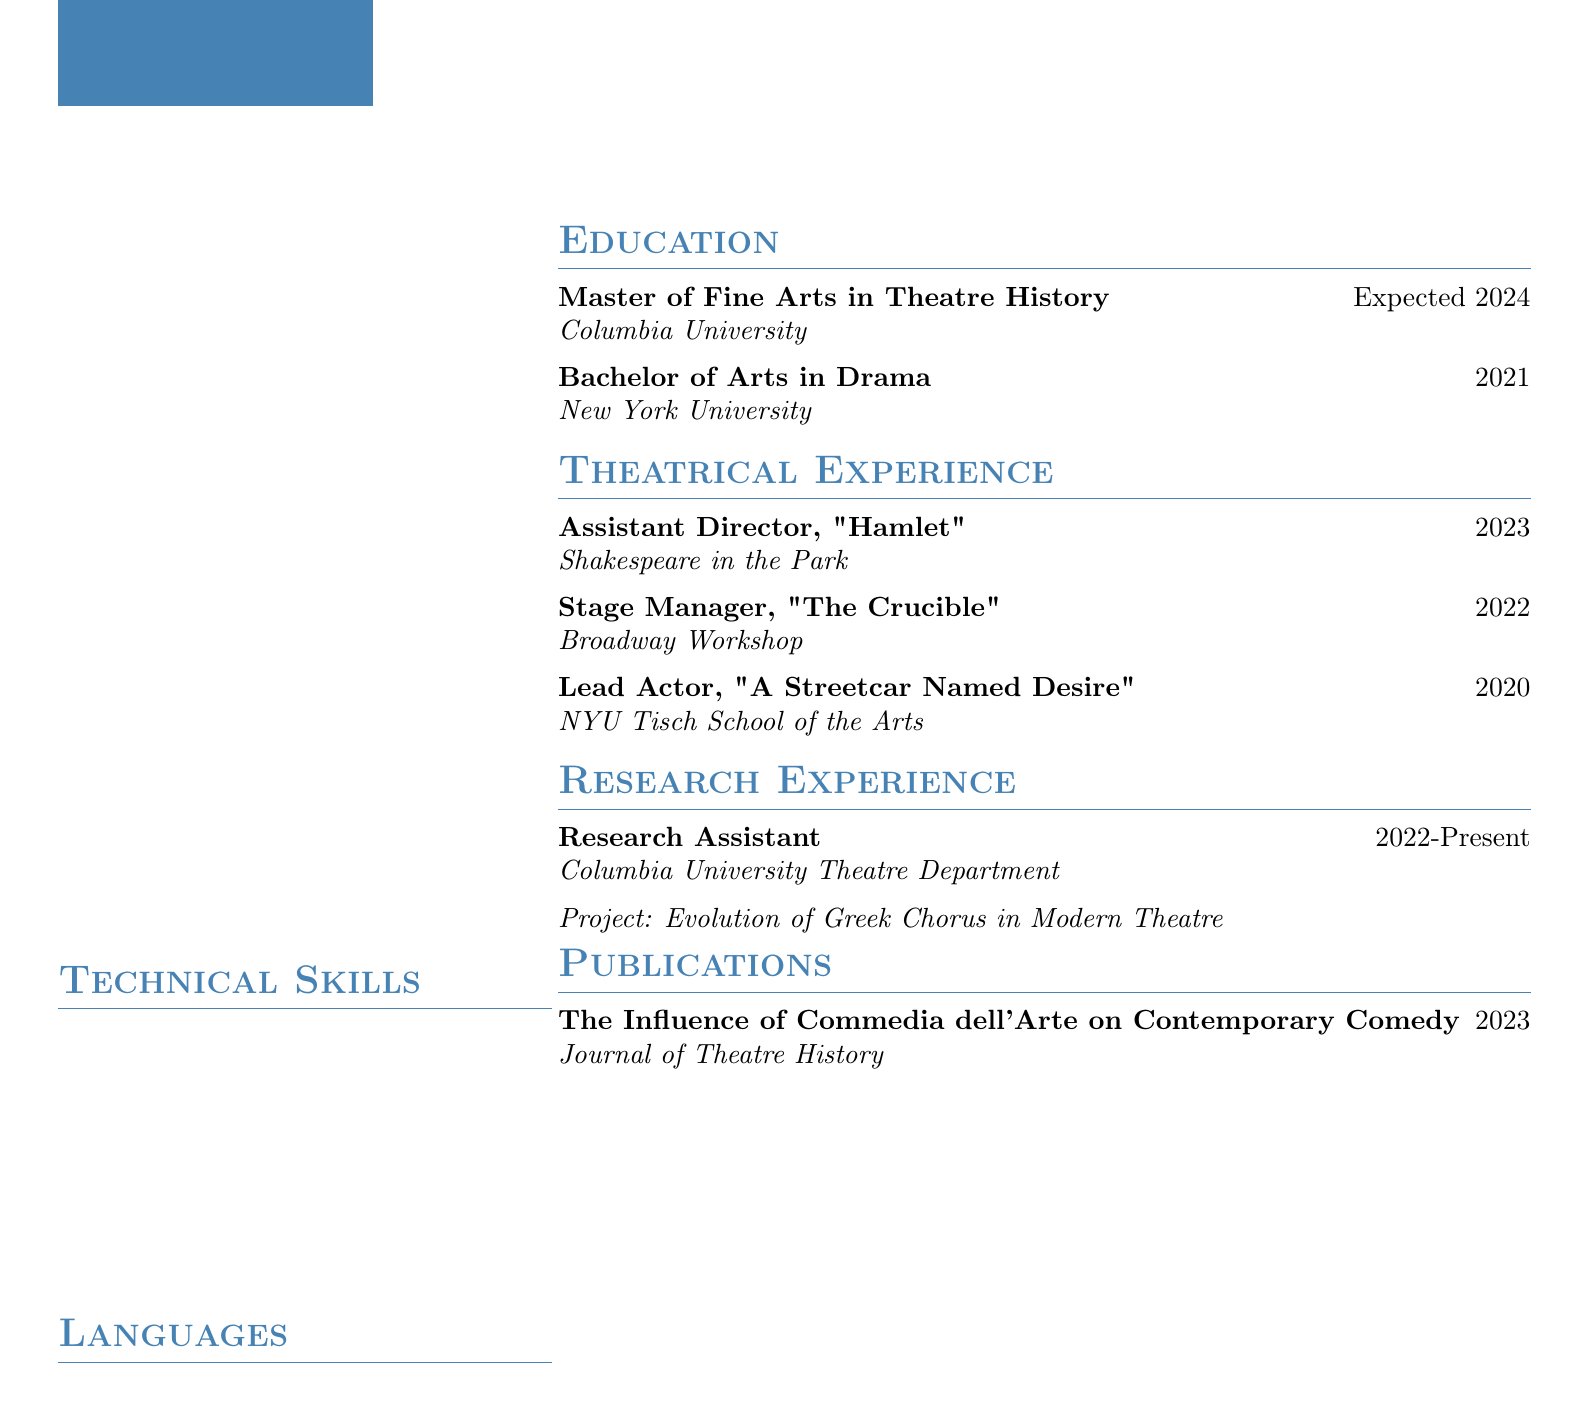What is the expected year of graduation? The expected year of graduation is listed under education.
Answer: 2024 Who was the lead actor in "A Streetcar Named Desire"? This information is found under theatrical experience regarding the production.
Answer: Emily Thornton What role did Emily Thornton play in "Hamlet"? The role is specified in the theatrical experience section.
Answer: Assistant Director What institution did Emily Thornton attend for her Bachelor's degree? The institution is mentioned in the education section of the document.
Answer: New York University How many technical skills are listed? Counting the items under technical skills provides this answer.
Answer: 4 What is the title of Emily's publication? This can be found in the publications section of the CV.
Answer: The Influence of Commedia dell'Arte on Contemporary Comedy In which theatre company did Emily serve as stage manager for "The Crucible"? The theatre company is listed in the theatrical experience section.
Answer: Broadway Workshop What research project is Emily involved in? This title is detailed in the research experience section.
Answer: Evolution of Greek Chorus in Modern Theatre How many languages can Emily speak? This is determined by counting the items listed under languages.
Answer: 3 